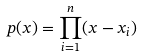Convert formula to latex. <formula><loc_0><loc_0><loc_500><loc_500>p ( x ) = \prod _ { i = 1 } ^ { n } ( x - x _ { i } )</formula> 